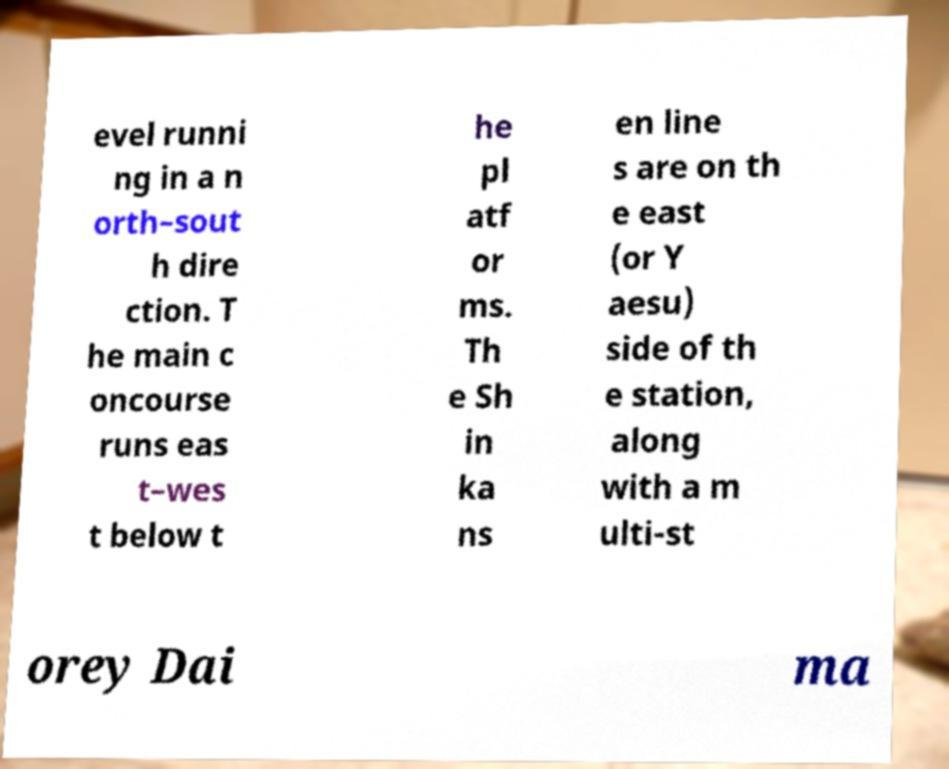There's text embedded in this image that I need extracted. Can you transcribe it verbatim? evel runni ng in a n orth–sout h dire ction. T he main c oncourse runs eas t–wes t below t he pl atf or ms. Th e Sh in ka ns en line s are on th e east (or Y aesu) side of th e station, along with a m ulti-st orey Dai ma 